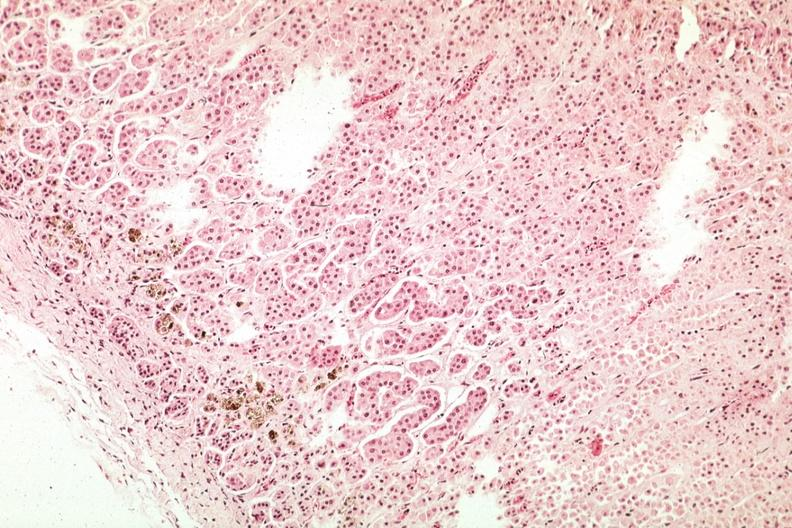s angiogram present?
Answer the question using a single word or phrase. No 